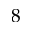<formula> <loc_0><loc_0><loc_500><loc_500>8</formula> 